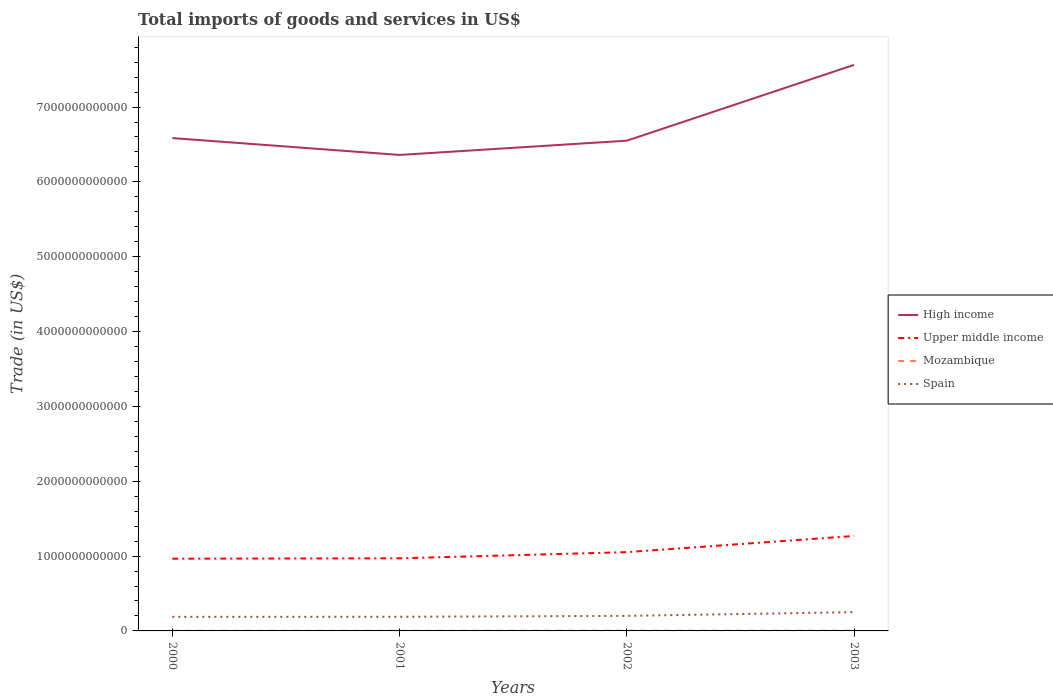How many different coloured lines are there?
Your answer should be very brief. 4. Does the line corresponding to Upper middle income intersect with the line corresponding to Mozambique?
Provide a succinct answer. No. Across all years, what is the maximum total imports of goods and services in High income?
Offer a very short reply. 6.36e+12. What is the total total imports of goods and services in Mozambique in the graph?
Make the answer very short. 3.50e+08. What is the difference between the highest and the second highest total imports of goods and services in Upper middle income?
Provide a succinct answer. 3.03e+11. What is the difference between the highest and the lowest total imports of goods and services in Upper middle income?
Your response must be concise. 1. What is the difference between two consecutive major ticks on the Y-axis?
Your answer should be very brief. 1.00e+12. Are the values on the major ticks of Y-axis written in scientific E-notation?
Your response must be concise. No. Does the graph contain grids?
Your response must be concise. No. Where does the legend appear in the graph?
Make the answer very short. Center right. How many legend labels are there?
Give a very brief answer. 4. How are the legend labels stacked?
Keep it short and to the point. Vertical. What is the title of the graph?
Your response must be concise. Total imports of goods and services in US$. Does "Jordan" appear as one of the legend labels in the graph?
Give a very brief answer. No. What is the label or title of the X-axis?
Offer a very short reply. Years. What is the label or title of the Y-axis?
Give a very brief answer. Trade (in US$). What is the Trade (in US$) in High income in 2000?
Offer a terse response. 6.59e+12. What is the Trade (in US$) of Upper middle income in 2000?
Give a very brief answer. 9.65e+11. What is the Trade (in US$) in Mozambique in 2000?
Offer a terse response. 1.98e+09. What is the Trade (in US$) in Spain in 2000?
Your answer should be compact. 1.88e+11. What is the Trade (in US$) in High income in 2001?
Offer a terse response. 6.36e+12. What is the Trade (in US$) of Upper middle income in 2001?
Your response must be concise. 9.70e+11. What is the Trade (in US$) of Mozambique in 2001?
Your response must be concise. 1.64e+09. What is the Trade (in US$) in Spain in 2001?
Keep it short and to the point. 1.89e+11. What is the Trade (in US$) in High income in 2002?
Provide a succinct answer. 6.55e+12. What is the Trade (in US$) of Upper middle income in 2002?
Offer a terse response. 1.05e+12. What is the Trade (in US$) in Mozambique in 2002?
Make the answer very short. 2.82e+09. What is the Trade (in US$) in Spain in 2002?
Offer a very short reply. 2.01e+11. What is the Trade (in US$) of High income in 2003?
Your response must be concise. 7.56e+12. What is the Trade (in US$) of Upper middle income in 2003?
Give a very brief answer. 1.27e+12. What is the Trade (in US$) of Mozambique in 2003?
Make the answer very short. 2.85e+09. What is the Trade (in US$) of Spain in 2003?
Give a very brief answer. 2.51e+11. Across all years, what is the maximum Trade (in US$) of High income?
Make the answer very short. 7.56e+12. Across all years, what is the maximum Trade (in US$) in Upper middle income?
Your answer should be very brief. 1.27e+12. Across all years, what is the maximum Trade (in US$) of Mozambique?
Keep it short and to the point. 2.85e+09. Across all years, what is the maximum Trade (in US$) in Spain?
Offer a terse response. 2.51e+11. Across all years, what is the minimum Trade (in US$) in High income?
Keep it short and to the point. 6.36e+12. Across all years, what is the minimum Trade (in US$) of Upper middle income?
Provide a succinct answer. 9.65e+11. Across all years, what is the minimum Trade (in US$) of Mozambique?
Offer a very short reply. 1.64e+09. Across all years, what is the minimum Trade (in US$) of Spain?
Offer a terse response. 1.88e+11. What is the total Trade (in US$) in High income in the graph?
Offer a very short reply. 2.71e+13. What is the total Trade (in US$) in Upper middle income in the graph?
Your answer should be compact. 4.26e+12. What is the total Trade (in US$) in Mozambique in the graph?
Keep it short and to the point. 9.29e+09. What is the total Trade (in US$) of Spain in the graph?
Your answer should be very brief. 8.29e+11. What is the difference between the Trade (in US$) of High income in 2000 and that in 2001?
Make the answer very short. 2.26e+11. What is the difference between the Trade (in US$) in Upper middle income in 2000 and that in 2001?
Provide a short and direct response. -4.89e+09. What is the difference between the Trade (in US$) in Mozambique in 2000 and that in 2001?
Offer a terse response. 3.50e+08. What is the difference between the Trade (in US$) of Spain in 2000 and that in 2001?
Offer a very short reply. -8.43e+08. What is the difference between the Trade (in US$) in High income in 2000 and that in 2002?
Offer a very short reply. 3.51e+1. What is the difference between the Trade (in US$) in Upper middle income in 2000 and that in 2002?
Your response must be concise. -8.75e+1. What is the difference between the Trade (in US$) in Mozambique in 2000 and that in 2002?
Your answer should be very brief. -8.33e+08. What is the difference between the Trade (in US$) in Spain in 2000 and that in 2002?
Offer a very short reply. -1.27e+1. What is the difference between the Trade (in US$) in High income in 2000 and that in 2003?
Provide a short and direct response. -9.78e+11. What is the difference between the Trade (in US$) in Upper middle income in 2000 and that in 2003?
Provide a short and direct response. -3.03e+11. What is the difference between the Trade (in US$) in Mozambique in 2000 and that in 2003?
Give a very brief answer. -8.67e+08. What is the difference between the Trade (in US$) in Spain in 2000 and that in 2003?
Your answer should be compact. -6.26e+1. What is the difference between the Trade (in US$) of High income in 2001 and that in 2002?
Give a very brief answer. -1.90e+11. What is the difference between the Trade (in US$) of Upper middle income in 2001 and that in 2002?
Your answer should be compact. -8.26e+1. What is the difference between the Trade (in US$) of Mozambique in 2001 and that in 2002?
Your answer should be very brief. -1.18e+09. What is the difference between the Trade (in US$) in Spain in 2001 and that in 2002?
Offer a terse response. -1.19e+1. What is the difference between the Trade (in US$) in High income in 2001 and that in 2003?
Give a very brief answer. -1.20e+12. What is the difference between the Trade (in US$) of Upper middle income in 2001 and that in 2003?
Provide a short and direct response. -2.99e+11. What is the difference between the Trade (in US$) of Mozambique in 2001 and that in 2003?
Ensure brevity in your answer.  -1.22e+09. What is the difference between the Trade (in US$) in Spain in 2001 and that in 2003?
Your answer should be compact. -6.18e+1. What is the difference between the Trade (in US$) in High income in 2002 and that in 2003?
Your response must be concise. -1.01e+12. What is the difference between the Trade (in US$) of Upper middle income in 2002 and that in 2003?
Keep it short and to the point. -2.16e+11. What is the difference between the Trade (in US$) in Mozambique in 2002 and that in 2003?
Offer a very short reply. -3.37e+07. What is the difference between the Trade (in US$) of Spain in 2002 and that in 2003?
Keep it short and to the point. -4.99e+1. What is the difference between the Trade (in US$) of High income in 2000 and the Trade (in US$) of Upper middle income in 2001?
Make the answer very short. 5.62e+12. What is the difference between the Trade (in US$) of High income in 2000 and the Trade (in US$) of Mozambique in 2001?
Provide a short and direct response. 6.58e+12. What is the difference between the Trade (in US$) of High income in 2000 and the Trade (in US$) of Spain in 2001?
Provide a short and direct response. 6.40e+12. What is the difference between the Trade (in US$) in Upper middle income in 2000 and the Trade (in US$) in Mozambique in 2001?
Make the answer very short. 9.64e+11. What is the difference between the Trade (in US$) of Upper middle income in 2000 and the Trade (in US$) of Spain in 2001?
Ensure brevity in your answer.  7.76e+11. What is the difference between the Trade (in US$) in Mozambique in 2000 and the Trade (in US$) in Spain in 2001?
Your answer should be compact. -1.87e+11. What is the difference between the Trade (in US$) of High income in 2000 and the Trade (in US$) of Upper middle income in 2002?
Provide a succinct answer. 5.53e+12. What is the difference between the Trade (in US$) in High income in 2000 and the Trade (in US$) in Mozambique in 2002?
Ensure brevity in your answer.  6.58e+12. What is the difference between the Trade (in US$) of High income in 2000 and the Trade (in US$) of Spain in 2002?
Offer a very short reply. 6.38e+12. What is the difference between the Trade (in US$) in Upper middle income in 2000 and the Trade (in US$) in Mozambique in 2002?
Your answer should be very brief. 9.62e+11. What is the difference between the Trade (in US$) in Upper middle income in 2000 and the Trade (in US$) in Spain in 2002?
Offer a terse response. 7.64e+11. What is the difference between the Trade (in US$) of Mozambique in 2000 and the Trade (in US$) of Spain in 2002?
Your response must be concise. -1.99e+11. What is the difference between the Trade (in US$) in High income in 2000 and the Trade (in US$) in Upper middle income in 2003?
Give a very brief answer. 5.32e+12. What is the difference between the Trade (in US$) of High income in 2000 and the Trade (in US$) of Mozambique in 2003?
Your response must be concise. 6.58e+12. What is the difference between the Trade (in US$) of High income in 2000 and the Trade (in US$) of Spain in 2003?
Provide a succinct answer. 6.33e+12. What is the difference between the Trade (in US$) of Upper middle income in 2000 and the Trade (in US$) of Mozambique in 2003?
Ensure brevity in your answer.  9.62e+11. What is the difference between the Trade (in US$) in Upper middle income in 2000 and the Trade (in US$) in Spain in 2003?
Your response must be concise. 7.14e+11. What is the difference between the Trade (in US$) of Mozambique in 2000 and the Trade (in US$) of Spain in 2003?
Make the answer very short. -2.49e+11. What is the difference between the Trade (in US$) of High income in 2001 and the Trade (in US$) of Upper middle income in 2002?
Offer a terse response. 5.31e+12. What is the difference between the Trade (in US$) of High income in 2001 and the Trade (in US$) of Mozambique in 2002?
Your response must be concise. 6.36e+12. What is the difference between the Trade (in US$) of High income in 2001 and the Trade (in US$) of Spain in 2002?
Keep it short and to the point. 6.16e+12. What is the difference between the Trade (in US$) in Upper middle income in 2001 and the Trade (in US$) in Mozambique in 2002?
Offer a very short reply. 9.67e+11. What is the difference between the Trade (in US$) in Upper middle income in 2001 and the Trade (in US$) in Spain in 2002?
Offer a very short reply. 7.69e+11. What is the difference between the Trade (in US$) in Mozambique in 2001 and the Trade (in US$) in Spain in 2002?
Make the answer very short. -1.99e+11. What is the difference between the Trade (in US$) in High income in 2001 and the Trade (in US$) in Upper middle income in 2003?
Your response must be concise. 5.09e+12. What is the difference between the Trade (in US$) of High income in 2001 and the Trade (in US$) of Mozambique in 2003?
Provide a short and direct response. 6.36e+12. What is the difference between the Trade (in US$) in High income in 2001 and the Trade (in US$) in Spain in 2003?
Provide a succinct answer. 6.11e+12. What is the difference between the Trade (in US$) of Upper middle income in 2001 and the Trade (in US$) of Mozambique in 2003?
Provide a succinct answer. 9.67e+11. What is the difference between the Trade (in US$) of Upper middle income in 2001 and the Trade (in US$) of Spain in 2003?
Your answer should be compact. 7.19e+11. What is the difference between the Trade (in US$) in Mozambique in 2001 and the Trade (in US$) in Spain in 2003?
Your answer should be very brief. -2.49e+11. What is the difference between the Trade (in US$) in High income in 2002 and the Trade (in US$) in Upper middle income in 2003?
Provide a short and direct response. 5.28e+12. What is the difference between the Trade (in US$) in High income in 2002 and the Trade (in US$) in Mozambique in 2003?
Your answer should be compact. 6.55e+12. What is the difference between the Trade (in US$) of High income in 2002 and the Trade (in US$) of Spain in 2003?
Your answer should be very brief. 6.30e+12. What is the difference between the Trade (in US$) of Upper middle income in 2002 and the Trade (in US$) of Mozambique in 2003?
Provide a succinct answer. 1.05e+12. What is the difference between the Trade (in US$) in Upper middle income in 2002 and the Trade (in US$) in Spain in 2003?
Your answer should be very brief. 8.02e+11. What is the difference between the Trade (in US$) of Mozambique in 2002 and the Trade (in US$) of Spain in 2003?
Keep it short and to the point. -2.48e+11. What is the average Trade (in US$) in High income per year?
Your answer should be very brief. 6.77e+12. What is the average Trade (in US$) of Upper middle income per year?
Offer a very short reply. 1.06e+12. What is the average Trade (in US$) in Mozambique per year?
Ensure brevity in your answer.  2.32e+09. What is the average Trade (in US$) of Spain per year?
Ensure brevity in your answer.  2.07e+11. In the year 2000, what is the difference between the Trade (in US$) in High income and Trade (in US$) in Upper middle income?
Make the answer very short. 5.62e+12. In the year 2000, what is the difference between the Trade (in US$) in High income and Trade (in US$) in Mozambique?
Give a very brief answer. 6.58e+12. In the year 2000, what is the difference between the Trade (in US$) of High income and Trade (in US$) of Spain?
Your answer should be very brief. 6.40e+12. In the year 2000, what is the difference between the Trade (in US$) of Upper middle income and Trade (in US$) of Mozambique?
Provide a succinct answer. 9.63e+11. In the year 2000, what is the difference between the Trade (in US$) in Upper middle income and Trade (in US$) in Spain?
Your answer should be compact. 7.77e+11. In the year 2000, what is the difference between the Trade (in US$) in Mozambique and Trade (in US$) in Spain?
Provide a succinct answer. -1.86e+11. In the year 2001, what is the difference between the Trade (in US$) in High income and Trade (in US$) in Upper middle income?
Give a very brief answer. 5.39e+12. In the year 2001, what is the difference between the Trade (in US$) in High income and Trade (in US$) in Mozambique?
Your answer should be very brief. 6.36e+12. In the year 2001, what is the difference between the Trade (in US$) in High income and Trade (in US$) in Spain?
Your answer should be compact. 6.17e+12. In the year 2001, what is the difference between the Trade (in US$) of Upper middle income and Trade (in US$) of Mozambique?
Offer a very short reply. 9.69e+11. In the year 2001, what is the difference between the Trade (in US$) of Upper middle income and Trade (in US$) of Spain?
Provide a succinct answer. 7.81e+11. In the year 2001, what is the difference between the Trade (in US$) of Mozambique and Trade (in US$) of Spain?
Keep it short and to the point. -1.87e+11. In the year 2002, what is the difference between the Trade (in US$) of High income and Trade (in US$) of Upper middle income?
Your answer should be very brief. 5.50e+12. In the year 2002, what is the difference between the Trade (in US$) in High income and Trade (in US$) in Mozambique?
Offer a very short reply. 6.55e+12. In the year 2002, what is the difference between the Trade (in US$) of High income and Trade (in US$) of Spain?
Offer a very short reply. 6.35e+12. In the year 2002, what is the difference between the Trade (in US$) of Upper middle income and Trade (in US$) of Mozambique?
Offer a terse response. 1.05e+12. In the year 2002, what is the difference between the Trade (in US$) of Upper middle income and Trade (in US$) of Spain?
Offer a very short reply. 8.52e+11. In the year 2002, what is the difference between the Trade (in US$) of Mozambique and Trade (in US$) of Spain?
Your response must be concise. -1.98e+11. In the year 2003, what is the difference between the Trade (in US$) in High income and Trade (in US$) in Upper middle income?
Offer a terse response. 6.30e+12. In the year 2003, what is the difference between the Trade (in US$) in High income and Trade (in US$) in Mozambique?
Offer a terse response. 7.56e+12. In the year 2003, what is the difference between the Trade (in US$) of High income and Trade (in US$) of Spain?
Give a very brief answer. 7.31e+12. In the year 2003, what is the difference between the Trade (in US$) of Upper middle income and Trade (in US$) of Mozambique?
Make the answer very short. 1.27e+12. In the year 2003, what is the difference between the Trade (in US$) of Upper middle income and Trade (in US$) of Spain?
Ensure brevity in your answer.  1.02e+12. In the year 2003, what is the difference between the Trade (in US$) in Mozambique and Trade (in US$) in Spain?
Your response must be concise. -2.48e+11. What is the ratio of the Trade (in US$) of High income in 2000 to that in 2001?
Your answer should be very brief. 1.04. What is the ratio of the Trade (in US$) of Mozambique in 2000 to that in 2001?
Your response must be concise. 1.21. What is the ratio of the Trade (in US$) in High income in 2000 to that in 2002?
Make the answer very short. 1.01. What is the ratio of the Trade (in US$) of Upper middle income in 2000 to that in 2002?
Keep it short and to the point. 0.92. What is the ratio of the Trade (in US$) of Mozambique in 2000 to that in 2002?
Give a very brief answer. 0.7. What is the ratio of the Trade (in US$) of Spain in 2000 to that in 2002?
Make the answer very short. 0.94. What is the ratio of the Trade (in US$) in High income in 2000 to that in 2003?
Keep it short and to the point. 0.87. What is the ratio of the Trade (in US$) in Upper middle income in 2000 to that in 2003?
Ensure brevity in your answer.  0.76. What is the ratio of the Trade (in US$) of Mozambique in 2000 to that in 2003?
Offer a very short reply. 0.7. What is the ratio of the Trade (in US$) in Spain in 2000 to that in 2003?
Offer a very short reply. 0.75. What is the ratio of the Trade (in US$) of High income in 2001 to that in 2002?
Keep it short and to the point. 0.97. What is the ratio of the Trade (in US$) in Upper middle income in 2001 to that in 2002?
Offer a very short reply. 0.92. What is the ratio of the Trade (in US$) in Mozambique in 2001 to that in 2002?
Ensure brevity in your answer.  0.58. What is the ratio of the Trade (in US$) of Spain in 2001 to that in 2002?
Your answer should be very brief. 0.94. What is the ratio of the Trade (in US$) in High income in 2001 to that in 2003?
Make the answer very short. 0.84. What is the ratio of the Trade (in US$) in Upper middle income in 2001 to that in 2003?
Give a very brief answer. 0.76. What is the ratio of the Trade (in US$) of Mozambique in 2001 to that in 2003?
Your answer should be very brief. 0.57. What is the ratio of the Trade (in US$) of Spain in 2001 to that in 2003?
Keep it short and to the point. 0.75. What is the ratio of the Trade (in US$) of High income in 2002 to that in 2003?
Your answer should be compact. 0.87. What is the ratio of the Trade (in US$) of Upper middle income in 2002 to that in 2003?
Keep it short and to the point. 0.83. What is the ratio of the Trade (in US$) in Spain in 2002 to that in 2003?
Your response must be concise. 0.8. What is the difference between the highest and the second highest Trade (in US$) in High income?
Your answer should be compact. 9.78e+11. What is the difference between the highest and the second highest Trade (in US$) in Upper middle income?
Keep it short and to the point. 2.16e+11. What is the difference between the highest and the second highest Trade (in US$) of Mozambique?
Keep it short and to the point. 3.37e+07. What is the difference between the highest and the second highest Trade (in US$) in Spain?
Your answer should be compact. 4.99e+1. What is the difference between the highest and the lowest Trade (in US$) of High income?
Provide a short and direct response. 1.20e+12. What is the difference between the highest and the lowest Trade (in US$) of Upper middle income?
Your answer should be compact. 3.03e+11. What is the difference between the highest and the lowest Trade (in US$) in Mozambique?
Provide a succinct answer. 1.22e+09. What is the difference between the highest and the lowest Trade (in US$) of Spain?
Provide a succinct answer. 6.26e+1. 